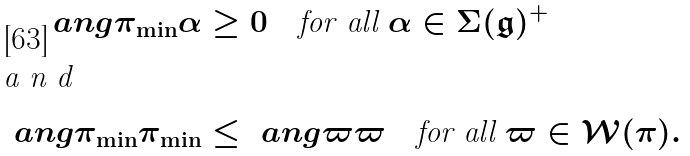<formula> <loc_0><loc_0><loc_500><loc_500>\ a n g { \pi _ { \min } } { \alpha } & \geq 0 \quad \text {for all } \alpha \in \Sigma ( \mathfrak g ) ^ { + } \\ \intertext { a n d } \ a n g { \pi _ { \min } } { \pi _ { \min } } & \leq \ a n g { \varpi } { \varpi } \quad \text {for all } \varpi \in \mathcal { W } ( \pi ) .</formula> 